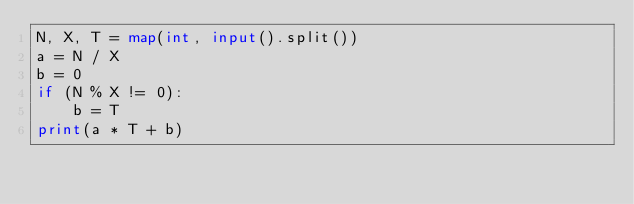<code> <loc_0><loc_0><loc_500><loc_500><_Python_>N, X, T = map(int, input().split())
a = N / X
b = 0
if (N % X != 0):
    b = T
print(a * T + b)
</code> 